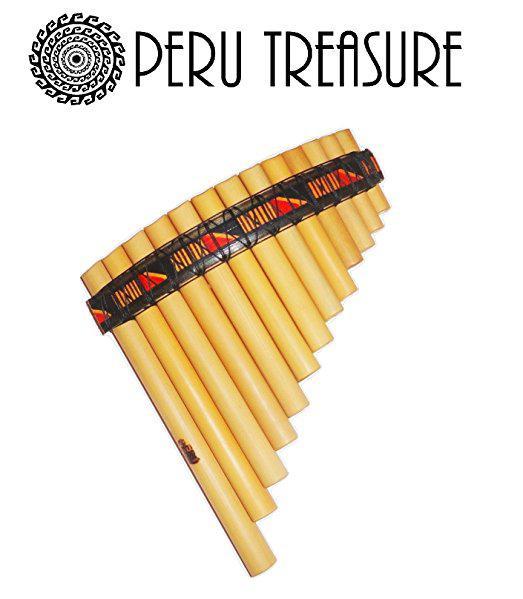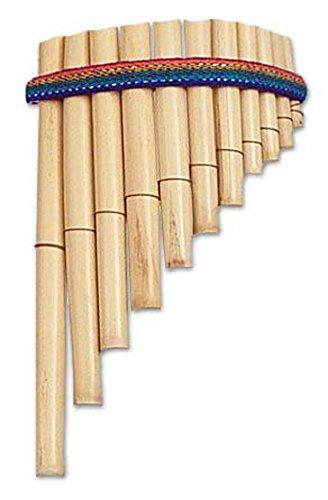The first image is the image on the left, the second image is the image on the right. For the images shown, is this caption "A carrying bag sits under the instrument in the image on the left." true? Answer yes or no. No. The first image is the image on the left, the second image is the image on the right. Examine the images to the left and right. Is the description "The right image features an instrument with pom-pom balls on each side displayed vertically, with its wooden tube shapes arranged left-to-right from shortest to longest." accurate? Answer yes or no. No. 